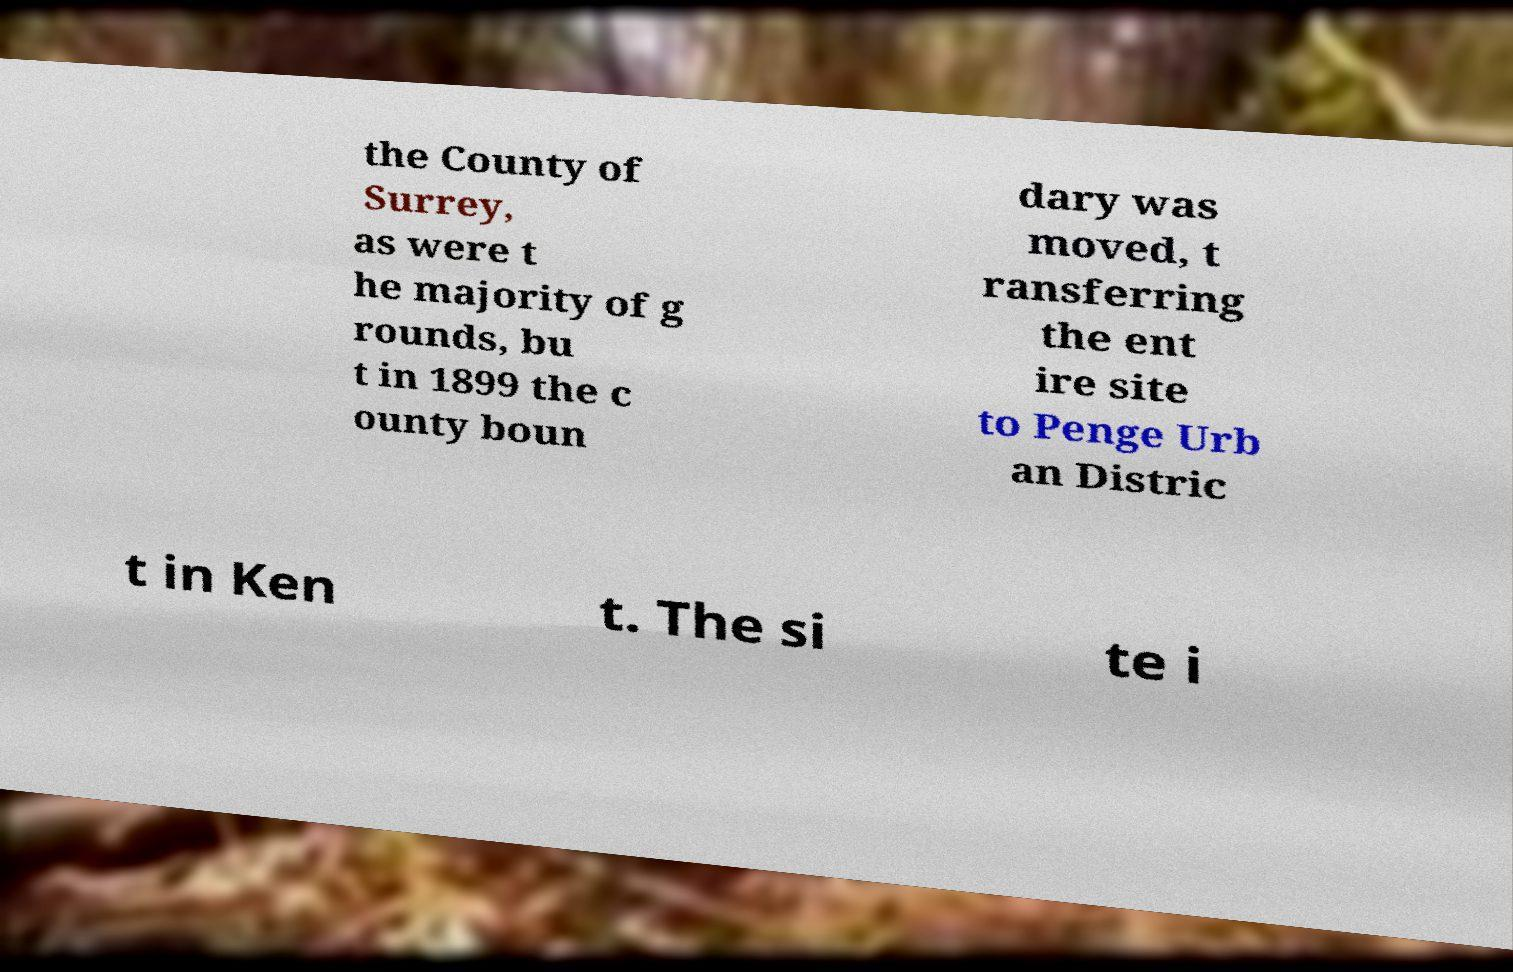I need the written content from this picture converted into text. Can you do that? the County of Surrey, as were t he majority of g rounds, bu t in 1899 the c ounty boun dary was moved, t ransferring the ent ire site to Penge Urb an Distric t in Ken t. The si te i 